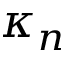<formula> <loc_0><loc_0><loc_500><loc_500>\kappa _ { n }</formula> 